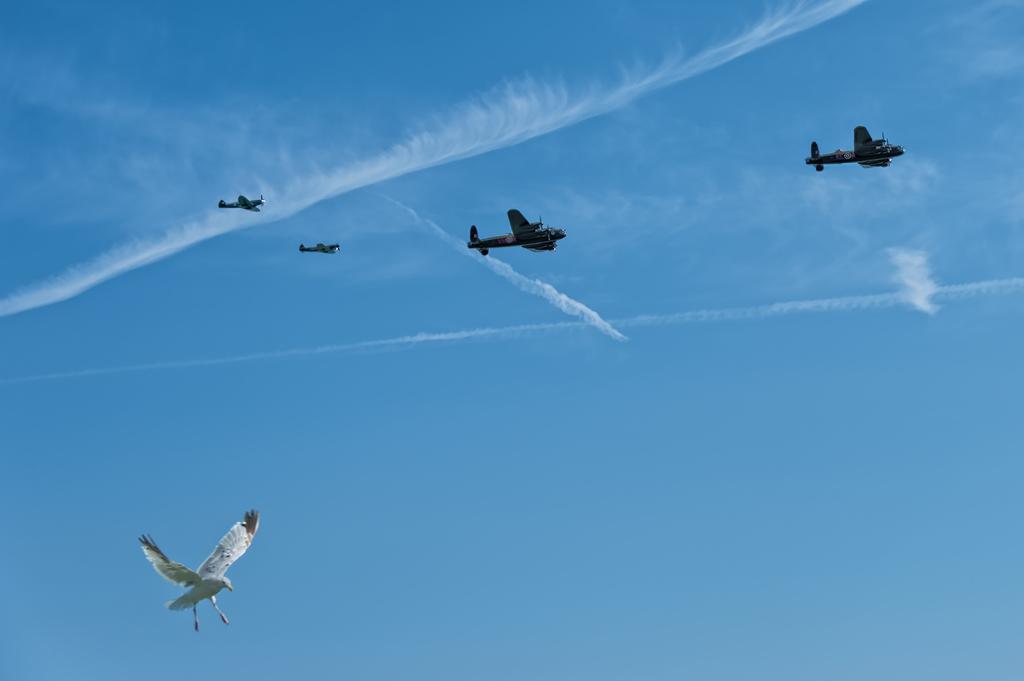Please provide a concise description of this image. In this image we can see a bird and some jet planes in the sky. 